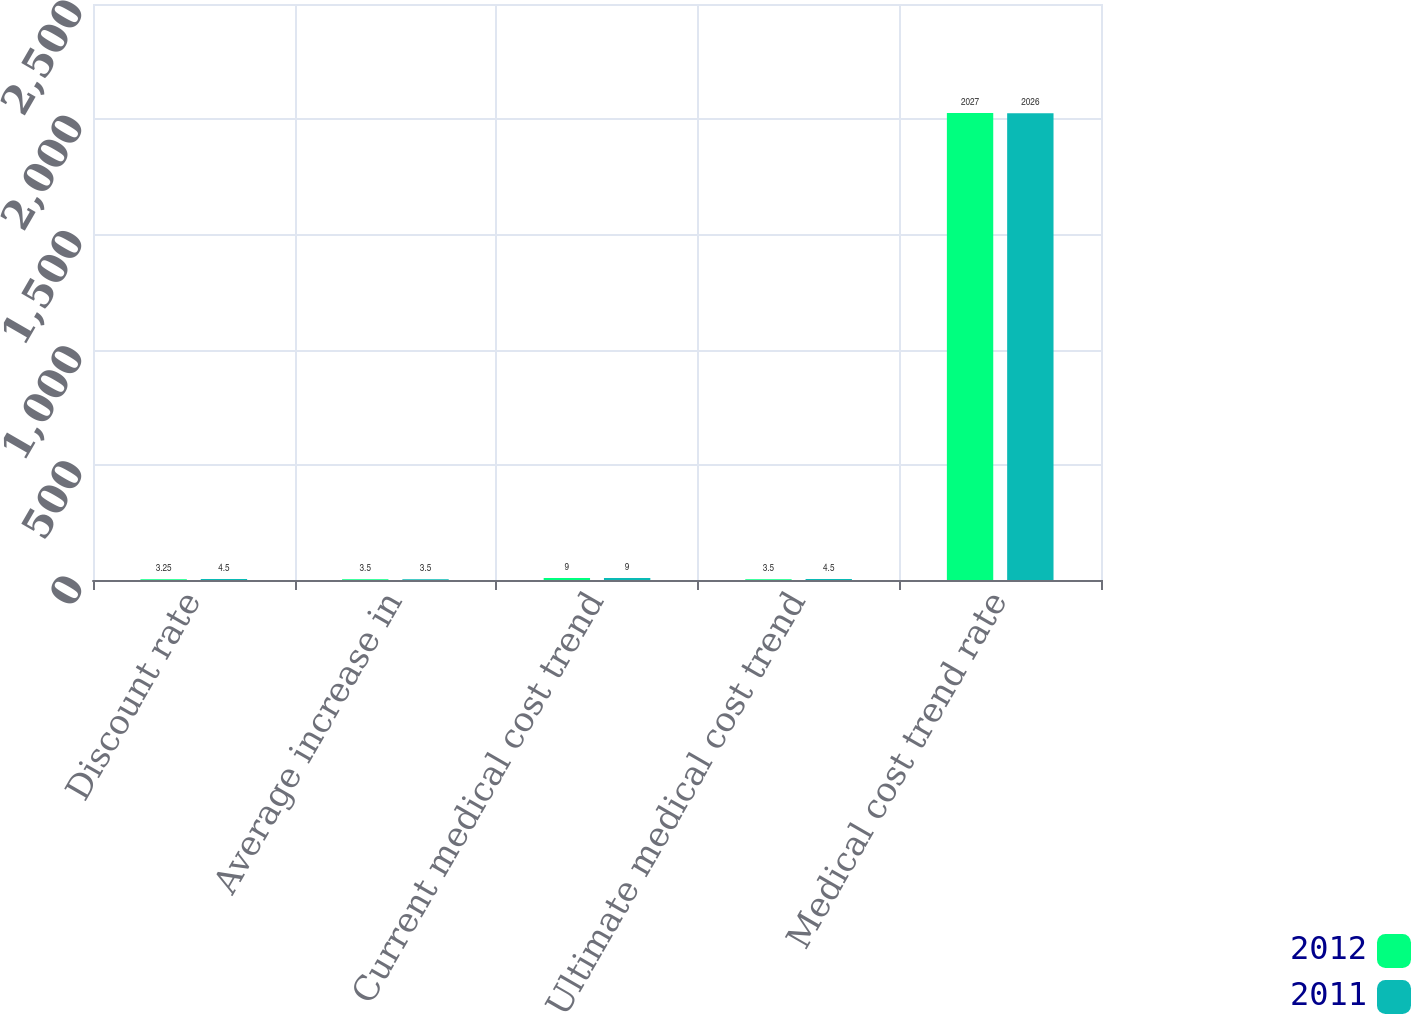Convert chart to OTSL. <chart><loc_0><loc_0><loc_500><loc_500><stacked_bar_chart><ecel><fcel>Discount rate<fcel>Average increase in<fcel>Current medical cost trend<fcel>Ultimate medical cost trend<fcel>Medical cost trend rate<nl><fcel>2012<fcel>3.25<fcel>3.5<fcel>9<fcel>3.5<fcel>2027<nl><fcel>2011<fcel>4.5<fcel>3.5<fcel>9<fcel>4.5<fcel>2026<nl></chart> 